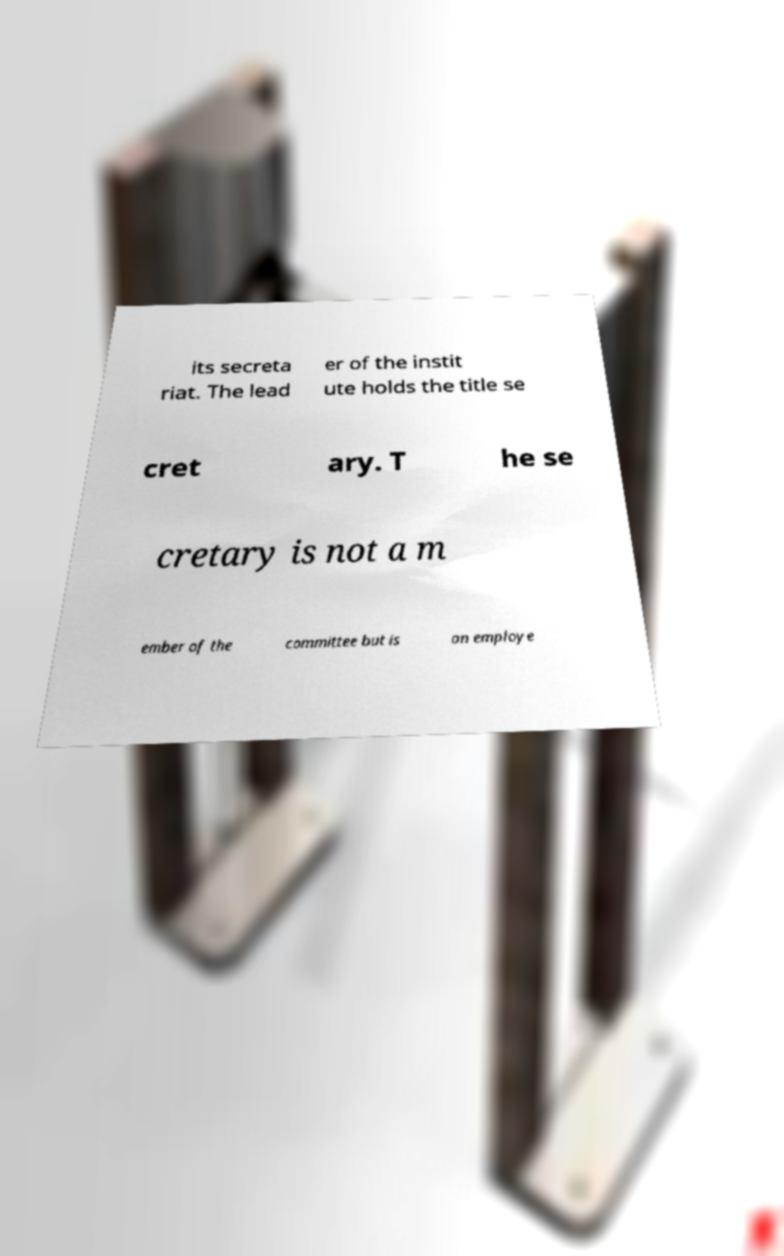Please identify and transcribe the text found in this image. its secreta riat. The lead er of the instit ute holds the title se cret ary. T he se cretary is not a m ember of the committee but is an employe 